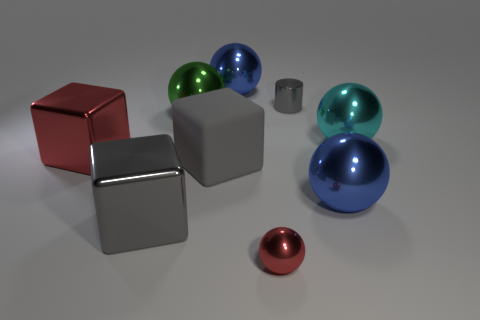The small thing that is the same color as the large matte cube is what shape?
Give a very brief answer. Cylinder. Are there more small cylinders that are in front of the gray cylinder than red metallic things on the right side of the large red metallic block?
Keep it short and to the point. No. What is the size of the metal cube that is the same color as the tiny metallic cylinder?
Your answer should be compact. Large. What number of other things are there of the same size as the red ball?
Your answer should be compact. 1. Does the large blue sphere behind the big cyan metal thing have the same material as the tiny cylinder?
Ensure brevity in your answer.  Yes. What number of other objects are there of the same color as the shiny cylinder?
Provide a short and direct response. 2. How many other things are the same shape as the large gray shiny object?
Provide a succinct answer. 2. There is a gray metallic thing in front of the large green metallic object; is its shape the same as the big blue thing that is behind the gray rubber cube?
Your answer should be compact. No. Are there the same number of tiny red things that are left of the big green sphere and big blue things behind the red ball?
Your answer should be very brief. No. There is a tiny metallic object that is in front of the metallic thing that is to the left of the metal cube that is in front of the big matte block; what is its shape?
Give a very brief answer. Sphere. 